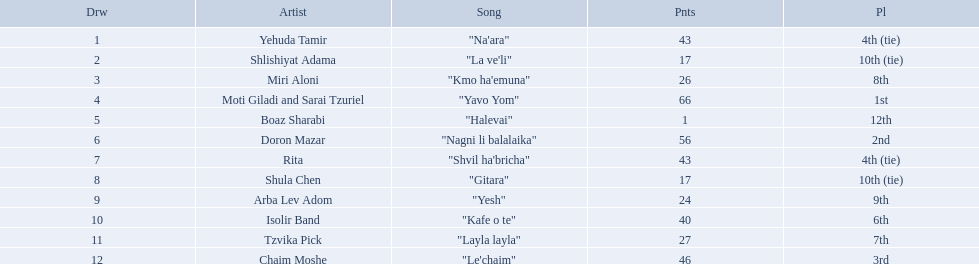Who were all the artists at the contest? Yehuda Tamir, Shlishiyat Adama, Miri Aloni, Moti Giladi and Sarai Tzuriel, Boaz Sharabi, Doron Mazar, Rita, Shula Chen, Arba Lev Adom, Isolir Band, Tzvika Pick, Chaim Moshe. What were their point totals? 43, 17, 26, 66, 1, 56, 43, 17, 24, 40, 27, 46. Of these, which is the least amount of points? 1. Which artists received this point total? Boaz Sharabi. Who are all of the artists? Yehuda Tamir, Shlishiyat Adama, Miri Aloni, Moti Giladi and Sarai Tzuriel, Boaz Sharabi, Doron Mazar, Rita, Shula Chen, Arba Lev Adom, Isolir Band, Tzvika Pick, Chaim Moshe. How many points did each score? 43, 17, 26, 66, 1, 56, 43, 17, 24, 40, 27, 46. And which artist had the least amount of points? Boaz Sharabi. 